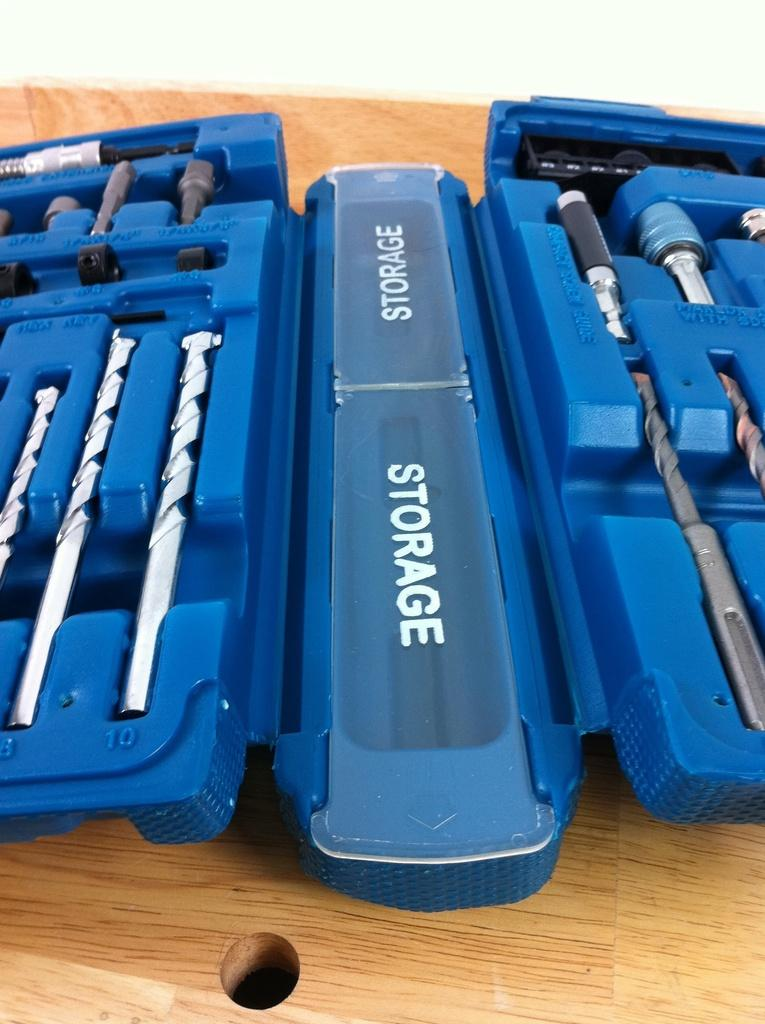What objects are in the image? There are tools in the image. Where are the tools located? The tools are in a tool box. What is the color of the surface the tool box is on? The tool box is on a brown surface. What color is the background of the image? The background of the image is white. What event is the queen attending in the image? There is no queen or event present in the image; it features tools in a tool box on a brown surface with a white background. 